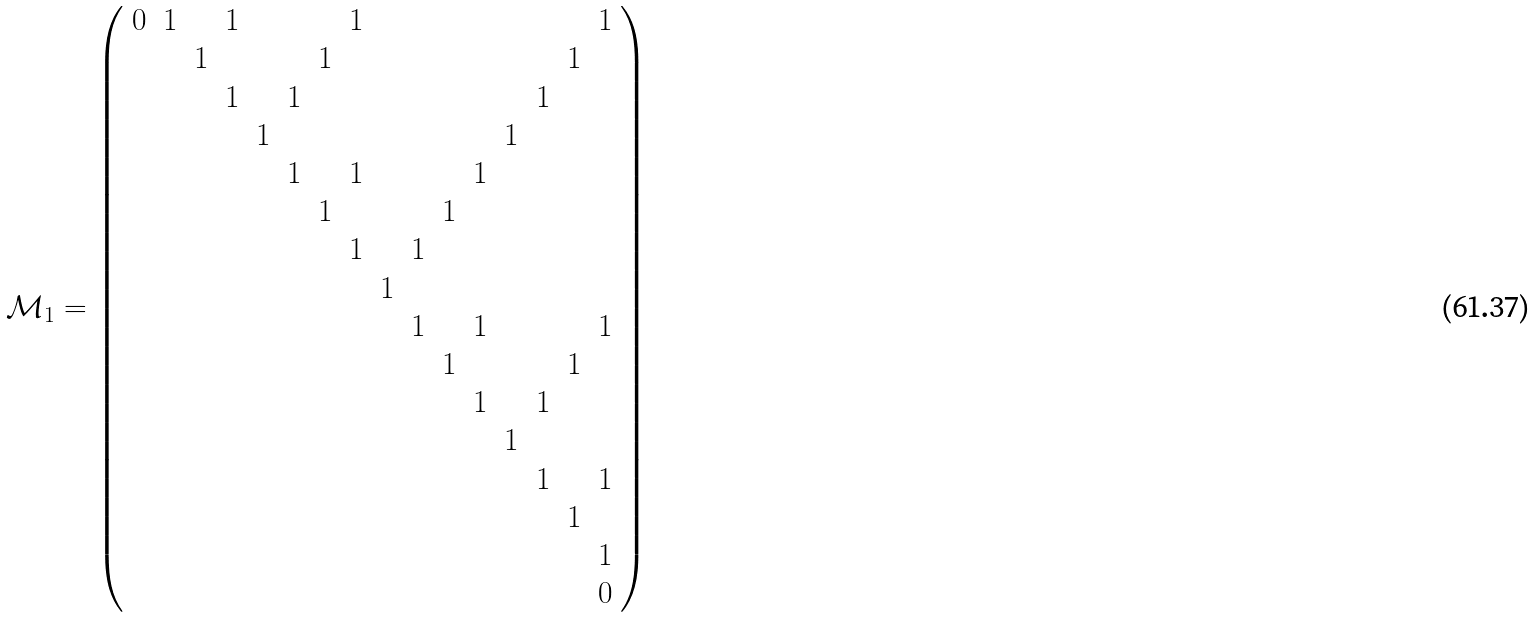<formula> <loc_0><loc_0><loc_500><loc_500>\mathcal { M } _ { 1 } = \left ( \begin{array} { r r r r r r r r r r r r r r r r } 0 & 1 & & 1 & & & & 1 & & & & & & & & 1 \\ & & 1 & & & & 1 & & & & & & & & 1 & \\ & & & 1 & & 1 & & & & & & & & 1 & & \\ & & & & 1 & & & & & & & & 1 & & & \\ & & & & & 1 & & 1 & & & & 1 & & & & \\ & & & & & & 1 & & & & 1 & & & & & \\ & & & & & & & 1 & & 1 & & & & & & \\ & & & & & & & & 1 & & & & & & & \\ & & & & & & & & & 1 & & 1 & & & & 1 \\ & & & & & & & & & & 1 & & & & 1 & \\ & & & & & & & & & & & 1 & & 1 & & \\ & & & & & & & & & & & & 1 & & & \\ & & & & & & & & & & & & & 1 & & 1 \\ & & & & & & & & & & & & & & 1 & \\ & & & & & & & & & & & & & & & 1 \\ & & & & & & & & & & & & & & & 0 \end{array} \right )</formula> 